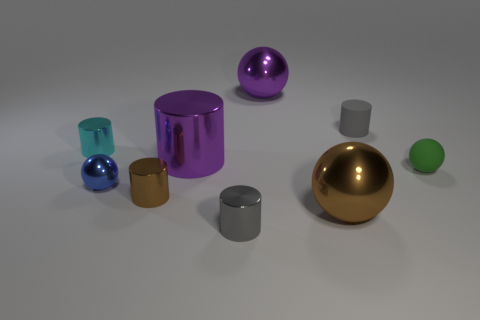Subtract 1 cylinders. How many cylinders are left? 4 Subtract all big metallic cylinders. How many cylinders are left? 4 Subtract all cyan cylinders. How many cylinders are left? 4 Add 1 large brown spheres. How many objects exist? 10 Subtract all cyan balls. Subtract all green cylinders. How many balls are left? 4 Subtract all cylinders. How many objects are left? 4 Subtract all big spheres. Subtract all large brown objects. How many objects are left? 6 Add 6 tiny brown metal objects. How many tiny brown metal objects are left? 7 Add 9 big yellow rubber blocks. How many big yellow rubber blocks exist? 9 Subtract 1 brown cylinders. How many objects are left? 8 